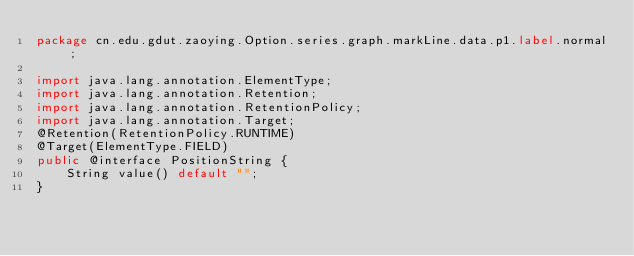<code> <loc_0><loc_0><loc_500><loc_500><_Java_>package cn.edu.gdut.zaoying.Option.series.graph.markLine.data.p1.label.normal;

import java.lang.annotation.ElementType;
import java.lang.annotation.Retention;
import java.lang.annotation.RetentionPolicy;
import java.lang.annotation.Target;
@Retention(RetentionPolicy.RUNTIME)
@Target(ElementType.FIELD)
public @interface PositionString {
    String value() default "";
}</code> 